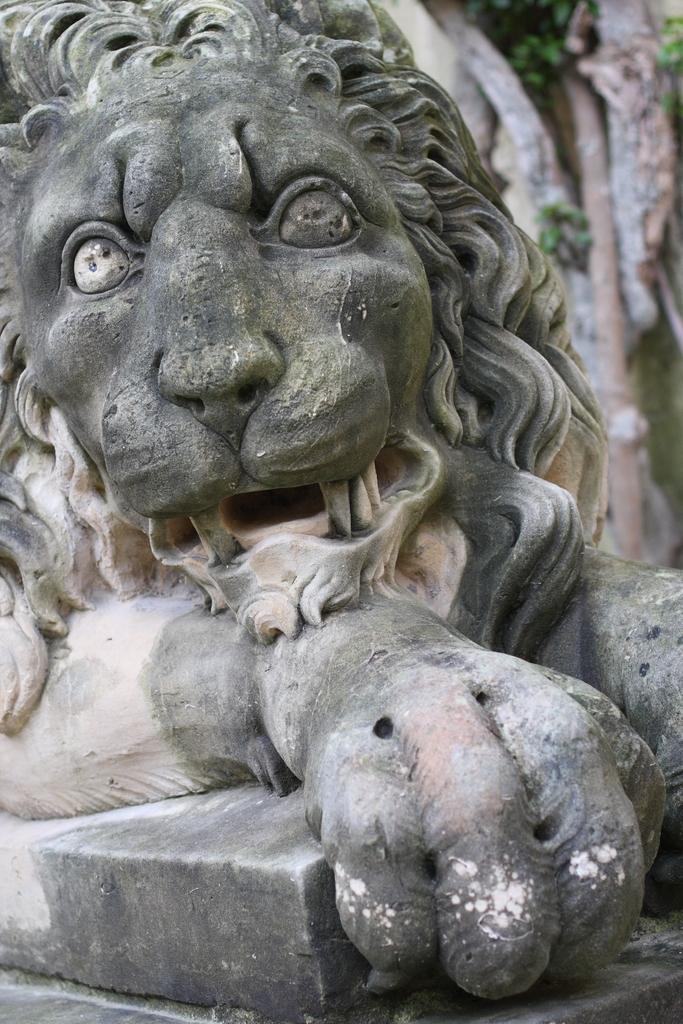Please provide a concise description of this image. In this image, we can see a sculpture of a lion. Right side background, we can see a blur view. Here we can see few plants, pole. 